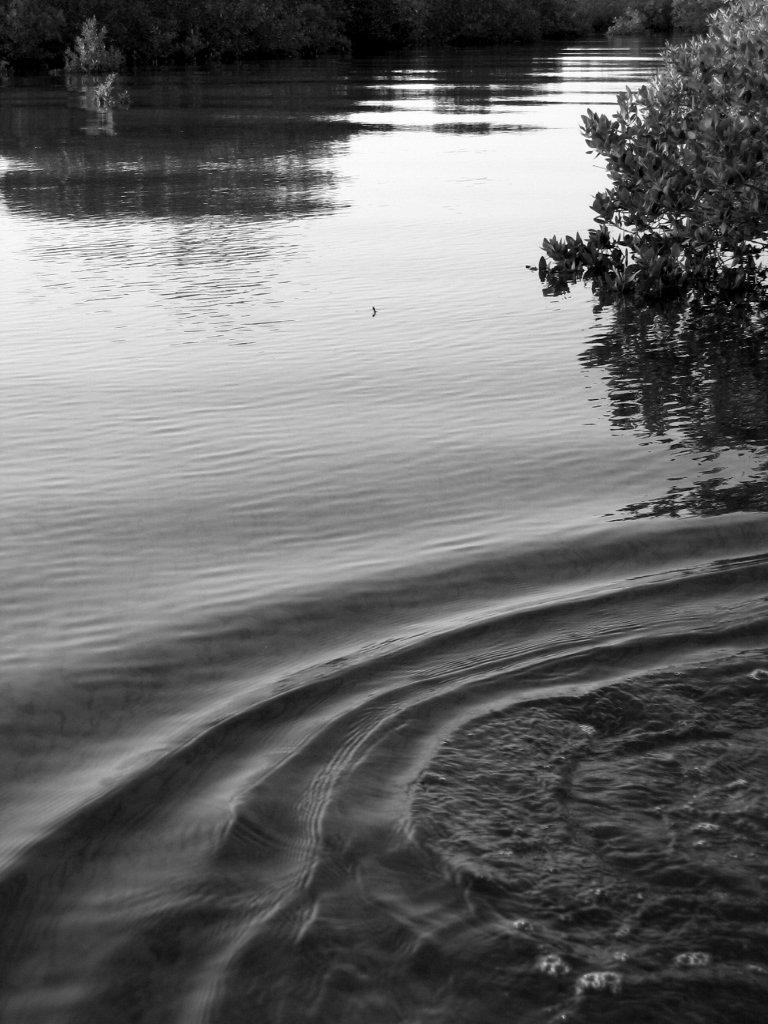What is the primary feature of the environment in the image? There is water around the area of the image. What type of vegetation can be seen in the image? There are plants at the top side of the image. Reasoning: Let's think step by identifying the main subjects and objects in the image based on the provided facts. We then formulate questions that focus on the location and characteristics of these subjects and objects, ensuring that each question can be answered definitively with the information given. We avoid yes/no questions and ensure that the language is simple and clear. Absurd Question/Answer: How many cows are present in the image? There are no cows present in the image. What type of bells can be heard ringing in the image? There are no bells present in the image, and therefore no sound can be heard. Is there a spy observing the area in the image? There is no indication of a spy or any surveillance activity in the image. 